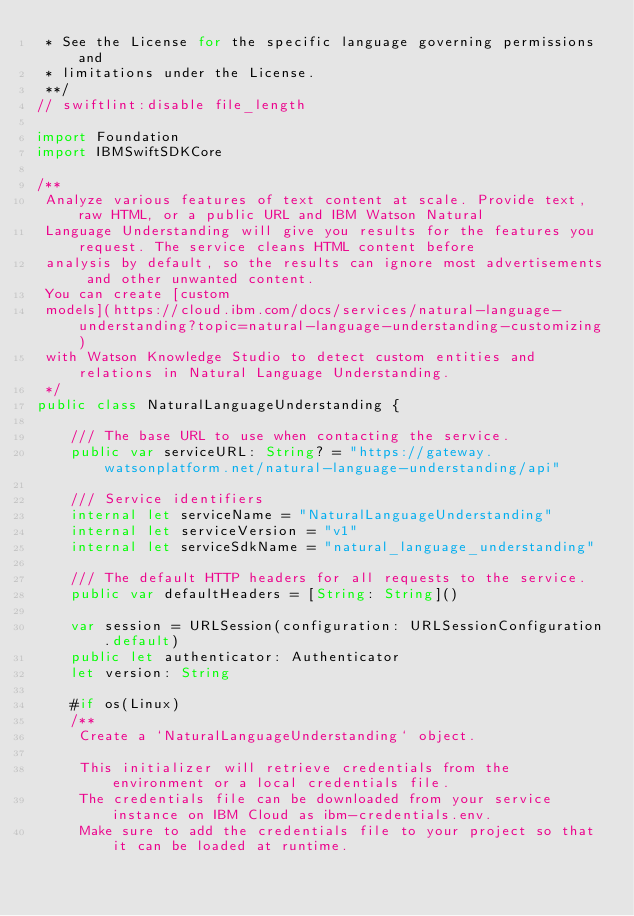<code> <loc_0><loc_0><loc_500><loc_500><_Swift_> * See the License for the specific language governing permissions and
 * limitations under the License.
 **/
// swiftlint:disable file_length

import Foundation
import IBMSwiftSDKCore

/**
 Analyze various features of text content at scale. Provide text, raw HTML, or a public URL and IBM Watson Natural
 Language Understanding will give you results for the features you request. The service cleans HTML content before
 analysis by default, so the results can ignore most advertisements and other unwanted content.
 You can create [custom
 models](https://cloud.ibm.com/docs/services/natural-language-understanding?topic=natural-language-understanding-customizing)
 with Watson Knowledge Studio to detect custom entities and relations in Natural Language Understanding.
 */
public class NaturalLanguageUnderstanding {

    /// The base URL to use when contacting the service.
    public var serviceURL: String? = "https://gateway.watsonplatform.net/natural-language-understanding/api"

    /// Service identifiers
    internal let serviceName = "NaturalLanguageUnderstanding"
    internal let serviceVersion = "v1"
    internal let serviceSdkName = "natural_language_understanding"

    /// The default HTTP headers for all requests to the service.
    public var defaultHeaders = [String: String]()

    var session = URLSession(configuration: URLSessionConfiguration.default)
    public let authenticator: Authenticator
    let version: String

    #if os(Linux)
    /**
     Create a `NaturalLanguageUnderstanding` object.

     This initializer will retrieve credentials from the environment or a local credentials file.
     The credentials file can be downloaded from your service instance on IBM Cloud as ibm-credentials.env.
     Make sure to add the credentials file to your project so that it can be loaded at runtime.
</code> 